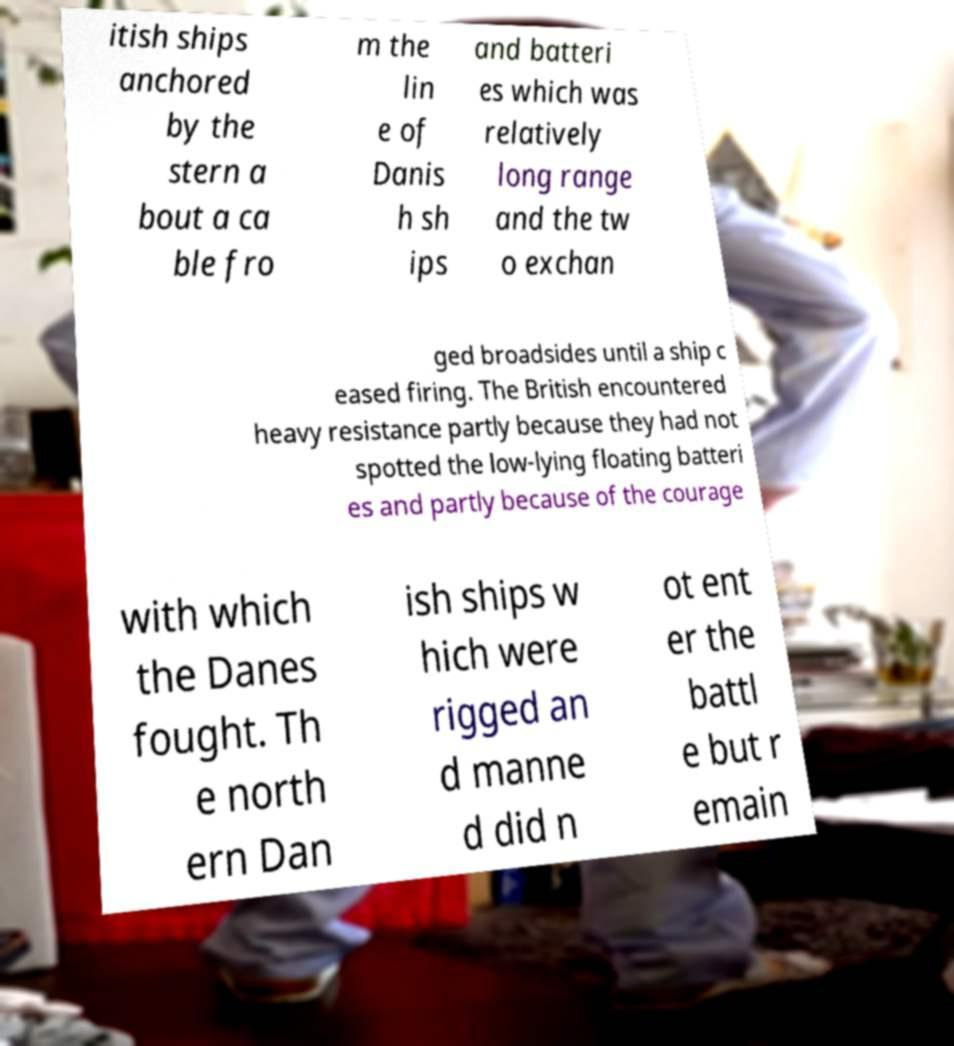Please identify and transcribe the text found in this image. itish ships anchored by the stern a bout a ca ble fro m the lin e of Danis h sh ips and batteri es which was relatively long range and the tw o exchan ged broadsides until a ship c eased firing. The British encountered heavy resistance partly because they had not spotted the low-lying floating batteri es and partly because of the courage with which the Danes fought. Th e north ern Dan ish ships w hich were rigged an d manne d did n ot ent er the battl e but r emain 